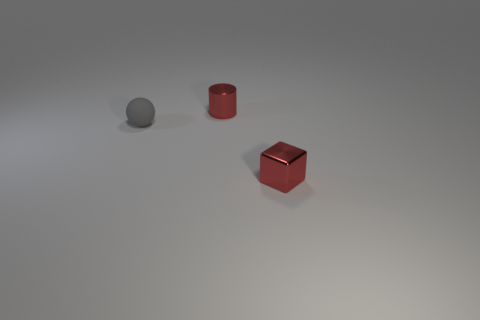There is a sphere; is it the same color as the tiny object behind the tiny matte object? No, the sphere is not the same color as the tiny object behind the tiny matte object. The sphere appears to be grey, while the small object behind the red, matte cylinder is itself red, matching the color of the cylinder. 